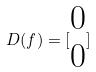Convert formula to latex. <formula><loc_0><loc_0><loc_500><loc_500>D ( f ) = [ \begin{matrix} 0 \\ 0 \end{matrix} ]</formula> 